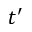<formula> <loc_0><loc_0><loc_500><loc_500>t ^ { \prime }</formula> 